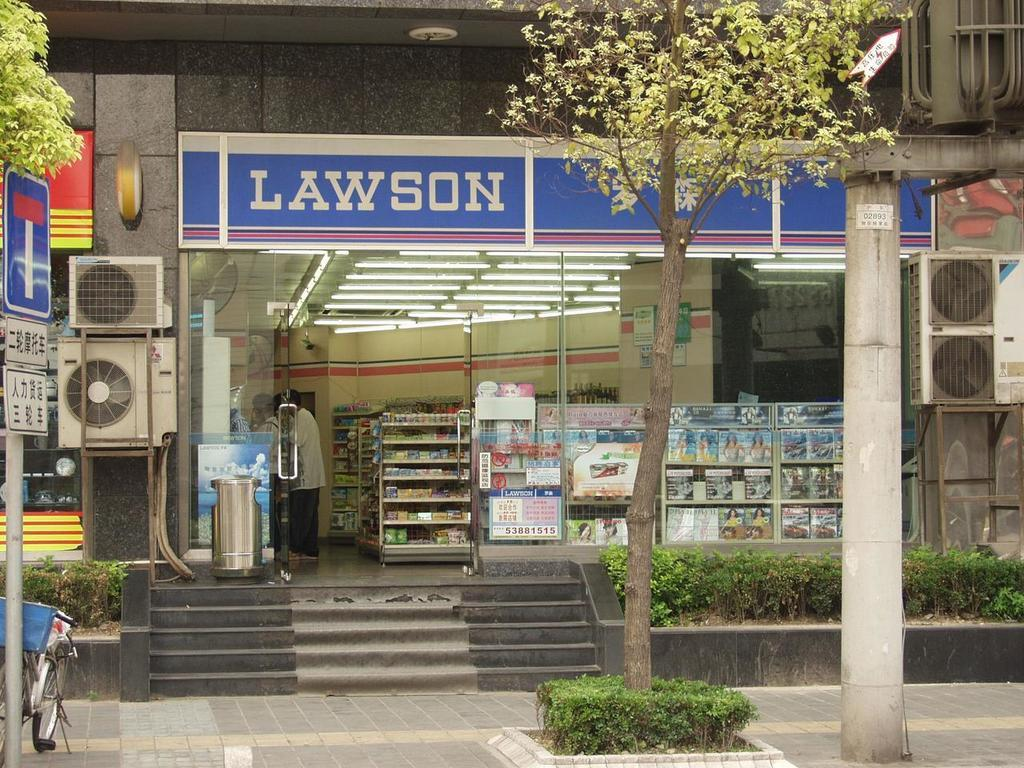<image>
Describe the image concisely. Store front with a blue sign that says LAWSON on it. 